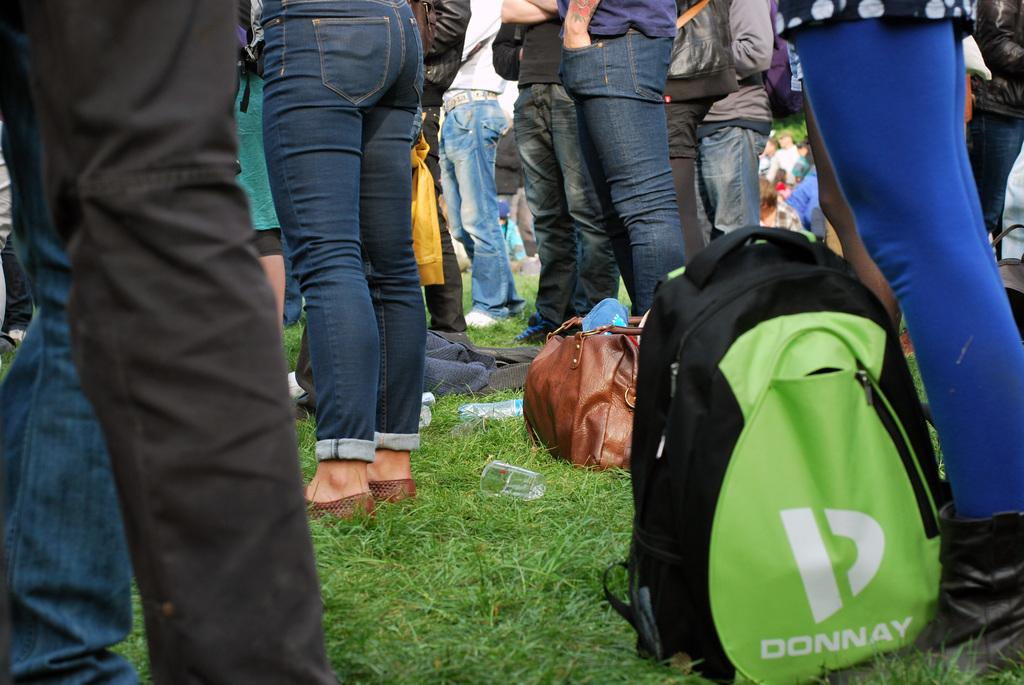What is the main subject of the image? The main subject of the image is a group of people. Where are the people located in the image? The people are standing on the grass. What object can be seen in the image besides the people? There is a bag visible in the image. What disease is affecting the people in the image? There is no indication of any disease affecting the people in the image. 